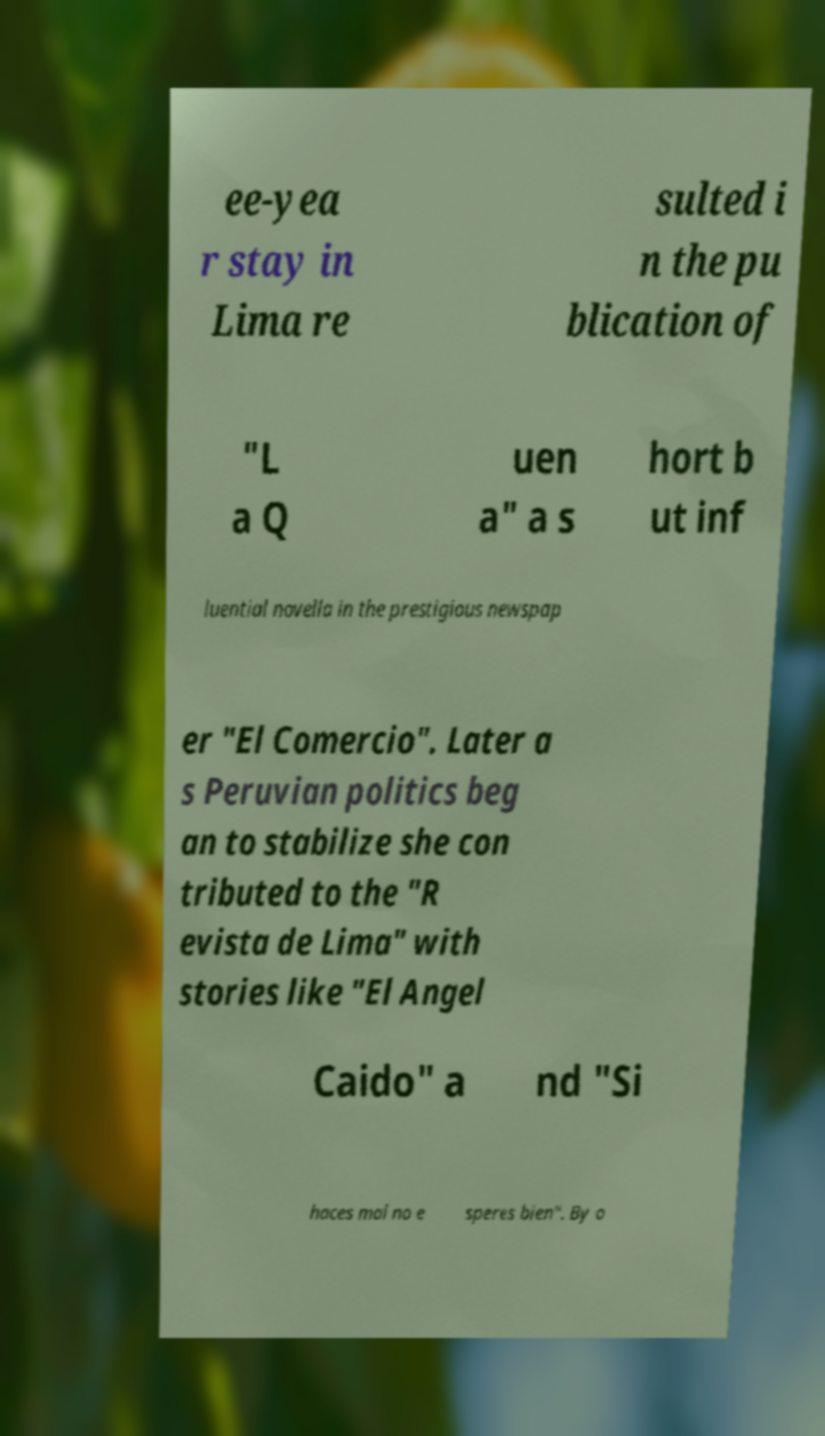There's text embedded in this image that I need extracted. Can you transcribe it verbatim? ee-yea r stay in Lima re sulted i n the pu blication of "L a Q uen a" a s hort b ut inf luential novella in the prestigious newspap er "El Comercio". Later a s Peruvian politics beg an to stabilize she con tributed to the "R evista de Lima" with stories like "El Angel Caido" a nd "Si haces mal no e speres bien". By o 